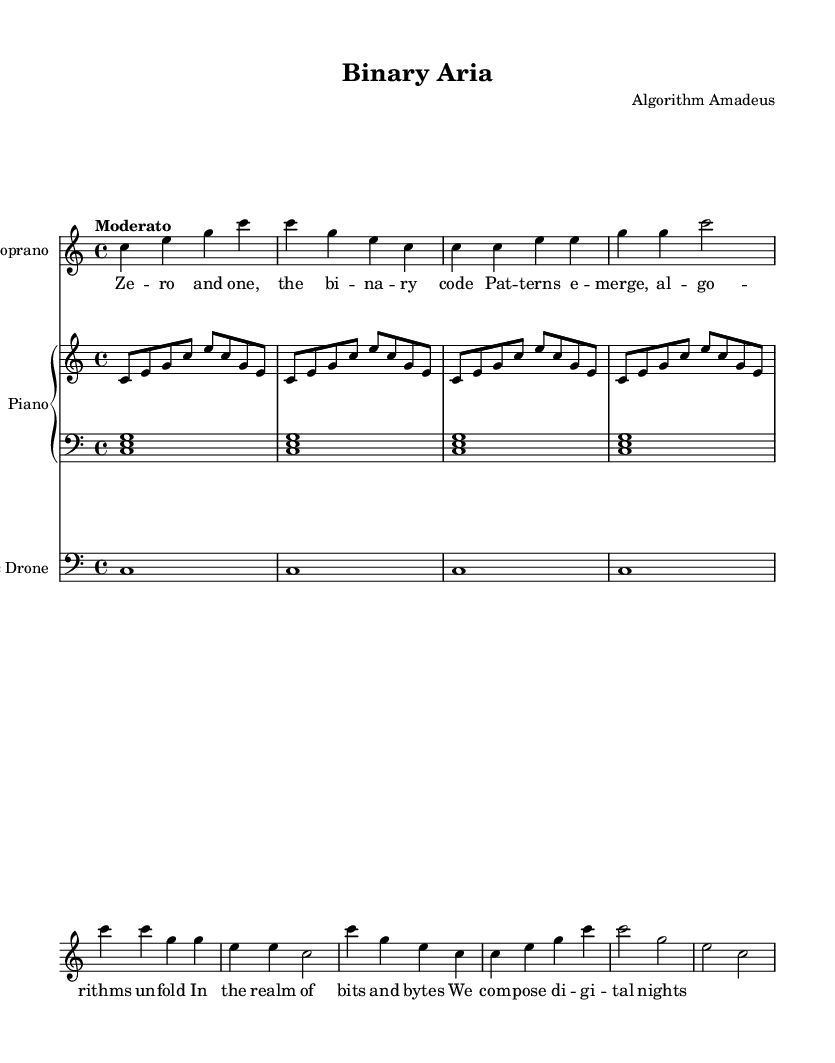What is the title of this piece? The title is indicated in the header section of the sheet music, where it states "Binary Aria."
Answer: Binary Aria What is the composer’s name? The composer's name is also found in the header section, listed as "Algorithm Amadeus."
Answer: Algorithm Amadeus What is the time signature of this piece? The time signature is found in the global settings at the start, reading "4/4."
Answer: 4/4 What is the tempo marking for the piece? The tempo marking is included in the global section, expressed as "Moderato."
Answer: Moderato How many measures are in the soprano part? To find the number of measures, count the bars in the soprano line. There are eight measures in total.
Answer: 8 What is the primary key signature used in this opera? The key signature is specified in the global settings as "C major," which has no sharps or flats.
Answer: C major What is the main theme of the lyrics in this opera? The lyrics indicate a theme about binary code and digital composition, which is evident during the repeated phrases in the verse.
Answer: Binary code 